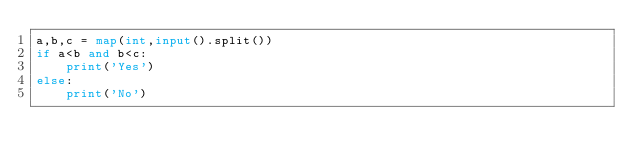<code> <loc_0><loc_0><loc_500><loc_500><_Python_>a,b,c = map(int,input().split())
if a<b and b<c:
    print('Yes')
else:
    print('No')
</code> 